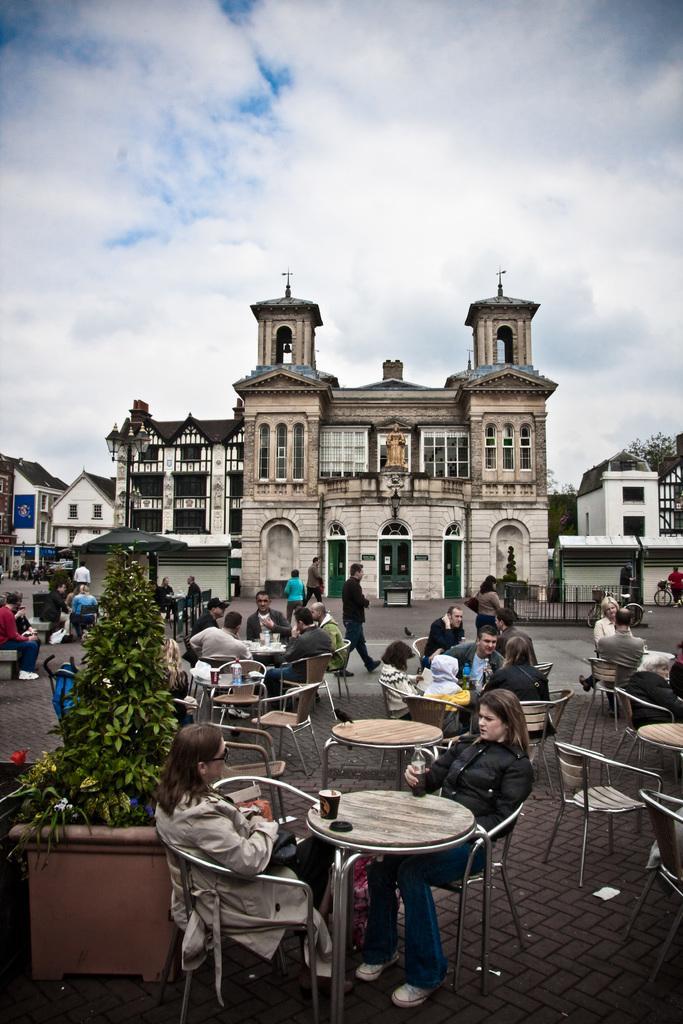Describe this image in one or two sentences. In this image in the center there are persons sitting and walking and On the left side there is a plant and there is tent which is black in colour. In the background there are buildings and the sky is cloudy. 